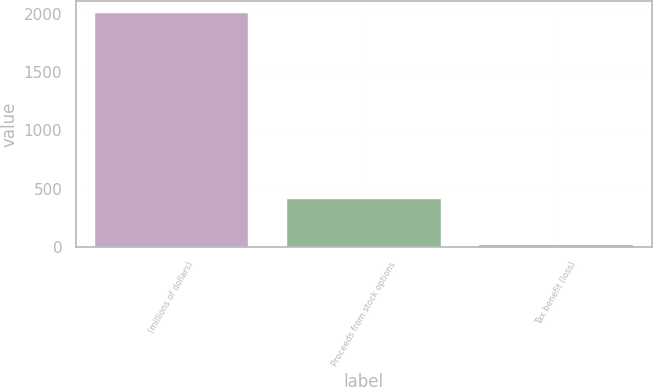<chart> <loc_0><loc_0><loc_500><loc_500><bar_chart><fcel>(millions of dollars)<fcel>Proceeds from stock options<fcel>Tax benefit (loss)<nl><fcel>2010<fcel>411.36<fcel>11.7<nl></chart> 